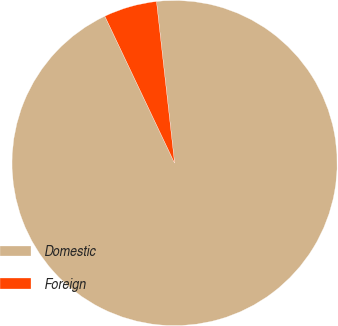Convert chart to OTSL. <chart><loc_0><loc_0><loc_500><loc_500><pie_chart><fcel>Domestic<fcel>Foreign<nl><fcel>94.72%<fcel>5.28%<nl></chart> 